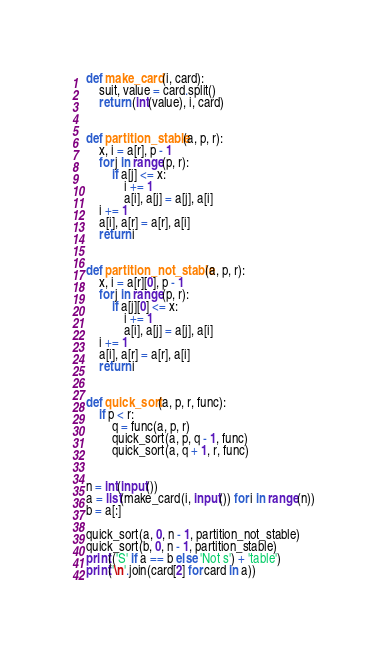<code> <loc_0><loc_0><loc_500><loc_500><_Python_>def make_card(i, card):
    suit, value = card.split()
    return (int(value), i, card)


def partition_stable(a, p, r):
    x, i = a[r], p - 1
    for j in range(p, r):
        if a[j] <= x:
            i += 1
            a[i], a[j] = a[j], a[i]
    i += 1
    a[i], a[r] = a[r], a[i]
    return i


def partition_not_stable(a, p, r):
    x, i = a[r][0], p - 1
    for j in range(p, r):
        if a[j][0] <= x:
            i += 1
            a[i], a[j] = a[j], a[i]
    i += 1
    a[i], a[r] = a[r], a[i]
    return i


def quick_sort(a, p, r, func):
    if p < r:
        q = func(a, p, r)
        quick_sort(a, p, q - 1, func)
        quick_sort(a, q + 1, r, func)


n = int(input())
a = list(make_card(i, input()) for i in range(n))
b = a[:]

quick_sort(a, 0, n - 1, partition_not_stable)
quick_sort(b, 0, n - 1, partition_stable)
print(('S' if a == b else 'Not s') + 'table')
print('\n'.join(card[2] for card in a))</code> 